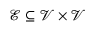Convert formula to latex. <formula><loc_0><loc_0><loc_500><loc_500>{ \mathcal { E } } \subseteq { \mathcal { V } } \times { \mathcal { V } }</formula> 